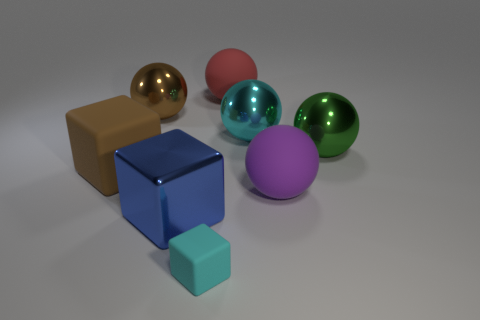Is there any other thing that has the same color as the small rubber thing?
Give a very brief answer. Yes. There is a rubber thing behind the shiny ball on the left side of the big blue metallic thing; what color is it?
Keep it short and to the point. Red. What number of big objects are green spheres or blue objects?
Provide a short and direct response. 2. There is a red object that is the same shape as the green thing; what is it made of?
Ensure brevity in your answer.  Rubber. Are there any other things that have the same material as the big purple thing?
Your answer should be compact. Yes. The metallic block has what color?
Offer a terse response. Blue. How many matte objects are on the right side of the big block behind the large blue metallic block?
Provide a succinct answer. 3. How big is the shiny thing that is left of the small object and in front of the brown metallic ball?
Provide a succinct answer. Large. There is a cyan sphere in front of the red object; what is its material?
Provide a short and direct response. Metal. Is there a brown shiny object that has the same shape as the large green metallic object?
Ensure brevity in your answer.  Yes. 